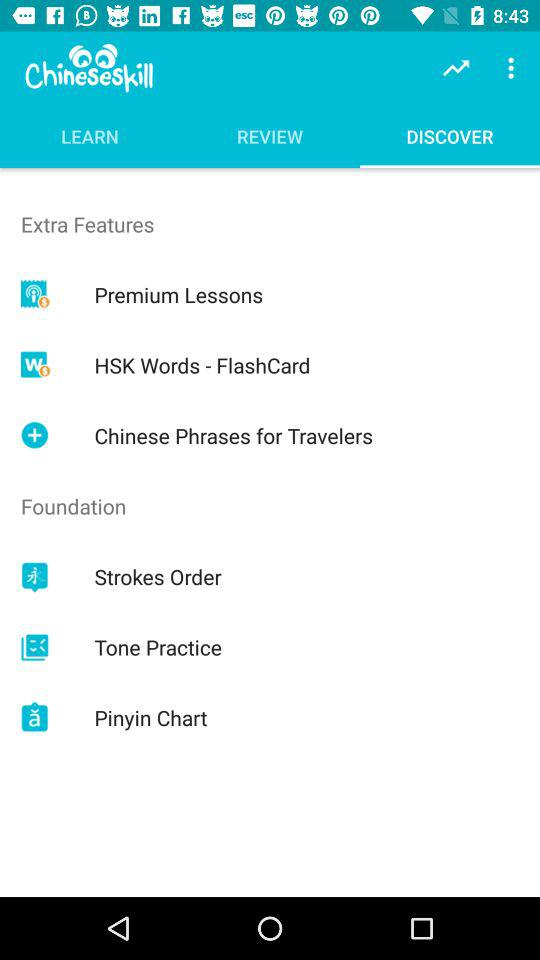What's the selected tab? The selected tab is "DISCOVER". 